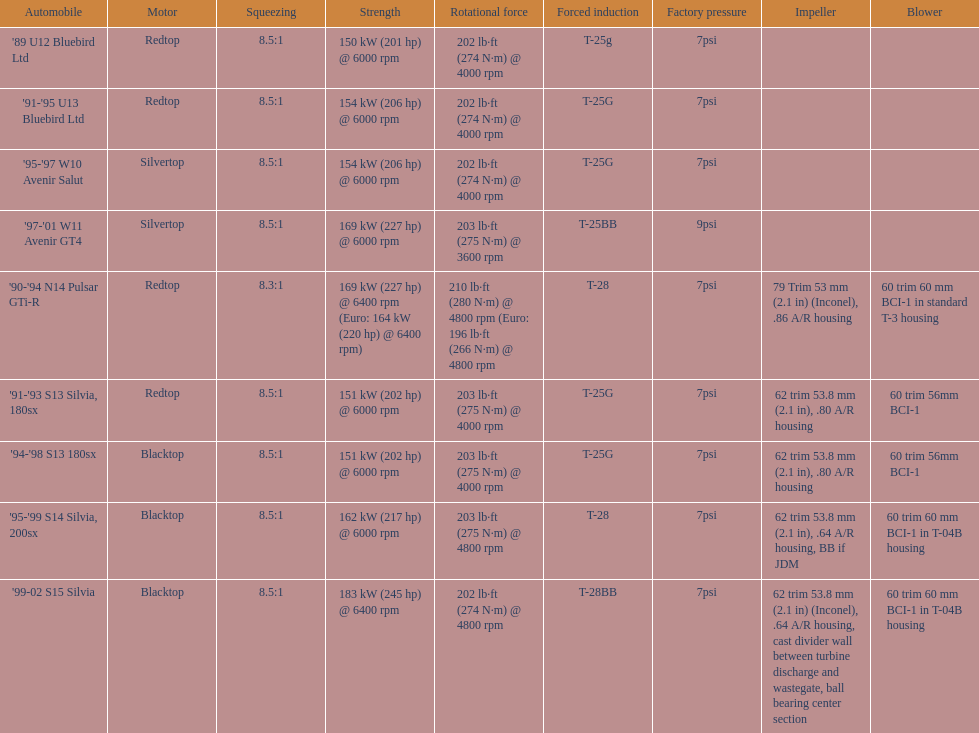Which engines are the same as the first entry ('89 u12 bluebird ltd)? '91-'95 U13 Bluebird Ltd, '90-'94 N14 Pulsar GTi-R, '91-'93 S13 Silvia, 180sx. 